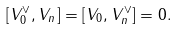<formula> <loc_0><loc_0><loc_500><loc_500>[ V _ { 0 } ^ { \vee } , V _ { n } ] = [ V _ { 0 } , V _ { n } ^ { \vee } ] = 0 .</formula> 